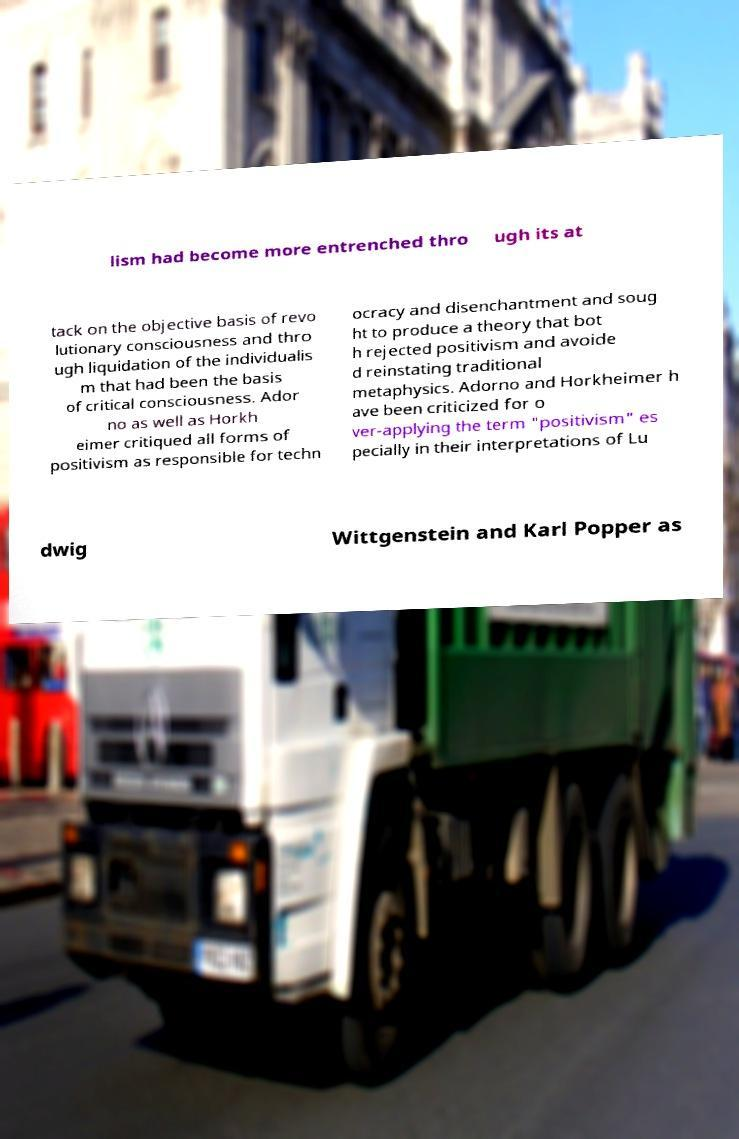Could you extract and type out the text from this image? lism had become more entrenched thro ugh its at tack on the objective basis of revo lutionary consciousness and thro ugh liquidation of the individualis m that had been the basis of critical consciousness. Ador no as well as Horkh eimer critiqued all forms of positivism as responsible for techn ocracy and disenchantment and soug ht to produce a theory that bot h rejected positivism and avoide d reinstating traditional metaphysics. Adorno and Horkheimer h ave been criticized for o ver-applying the term "positivism" es pecially in their interpretations of Lu dwig Wittgenstein and Karl Popper as 